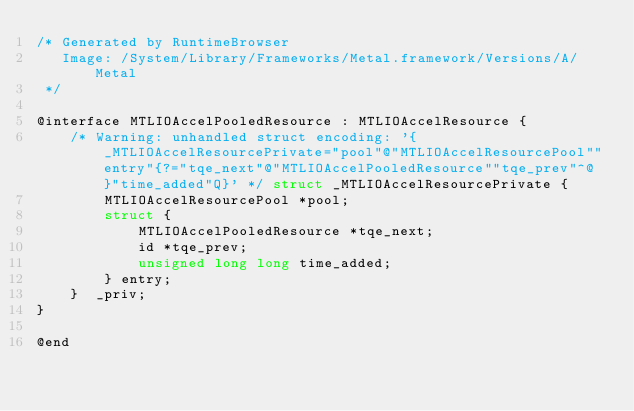Convert code to text. <code><loc_0><loc_0><loc_500><loc_500><_C_>/* Generated by RuntimeBrowser
   Image: /System/Library/Frameworks/Metal.framework/Versions/A/Metal
 */

@interface MTLIOAccelPooledResource : MTLIOAccelResource {
    /* Warning: unhandled struct encoding: '{_MTLIOAccelResourcePrivate="pool"@"MTLIOAccelResourcePool""entry"{?="tqe_next"@"MTLIOAccelPooledResource""tqe_prev"^@}"time_added"Q}' */ struct _MTLIOAccelResourcePrivate { 
        MTLIOAccelResourcePool *pool; 
        struct { 
            MTLIOAccelPooledResource *tqe_next; 
            id *tqe_prev; 
            unsigned long long time_added; 
        } entry; 
    }  _priv;
}

@end
</code> 